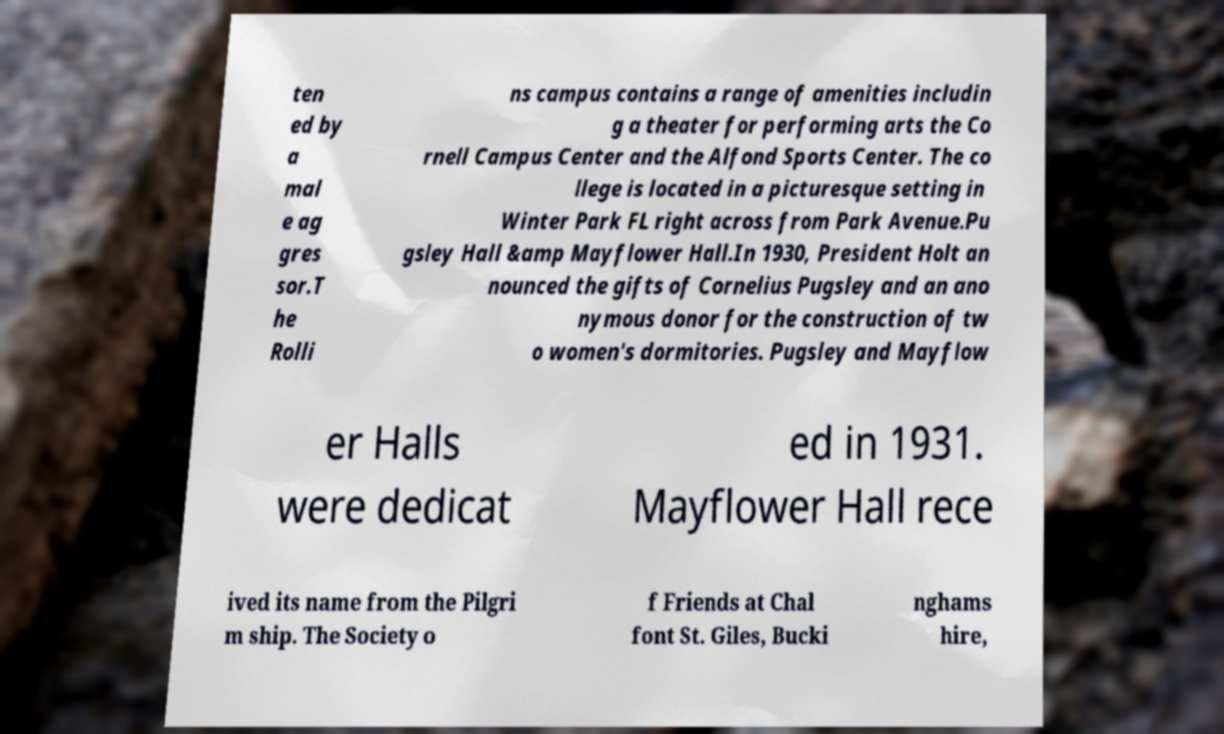Could you assist in decoding the text presented in this image and type it out clearly? ten ed by a mal e ag gres sor.T he Rolli ns campus contains a range of amenities includin g a theater for performing arts the Co rnell Campus Center and the Alfond Sports Center. The co llege is located in a picturesque setting in Winter Park FL right across from Park Avenue.Pu gsley Hall &amp Mayflower Hall.In 1930, President Holt an nounced the gifts of Cornelius Pugsley and an ano nymous donor for the construction of tw o women's dormitories. Pugsley and Mayflow er Halls were dedicat ed in 1931. Mayflower Hall rece ived its name from the Pilgri m ship. The Society o f Friends at Chal font St. Giles, Bucki nghams hire, 